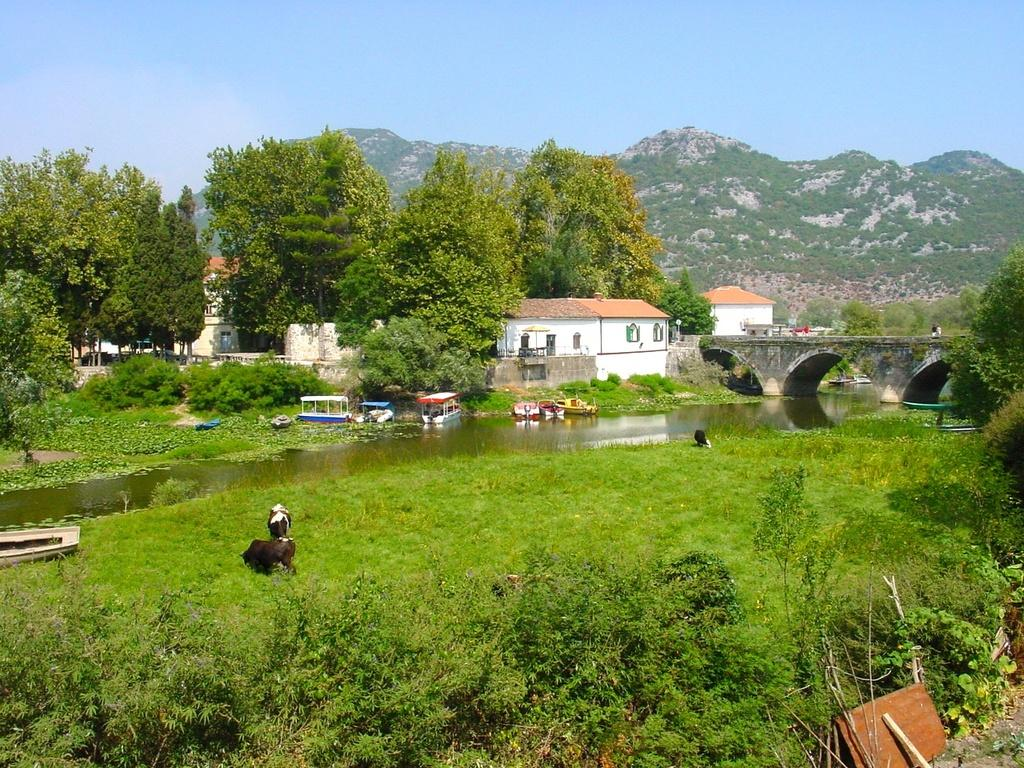What type of natural features can be seen in the image? There are trees and mountains in the image. What type of human-made structures can be seen in the image? There are small houses, a bridge, and boats in the image. What type of water feature is present in the image? There is a small river in the image. Can you describe the animal present in the image? There is a goat sitting in the image. What type of temper does the frame of the image have? There is no frame present in the image, so it does not have a temper. What color is the marble in the image? There is no marble present in the image. 